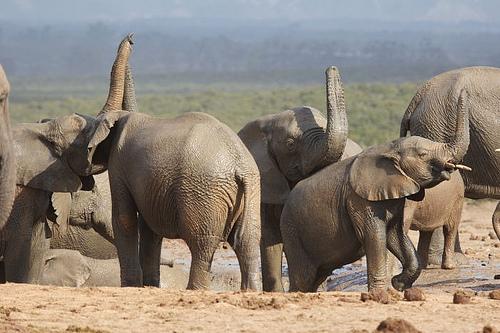How far are these elephants allowed to roam?
Quick response, please. Far. What is in the background?
Answer briefly. Grass. How many trunks are raised?
Give a very brief answer. 4. Are there young elephants in the picture?
Concise answer only. Yes. 